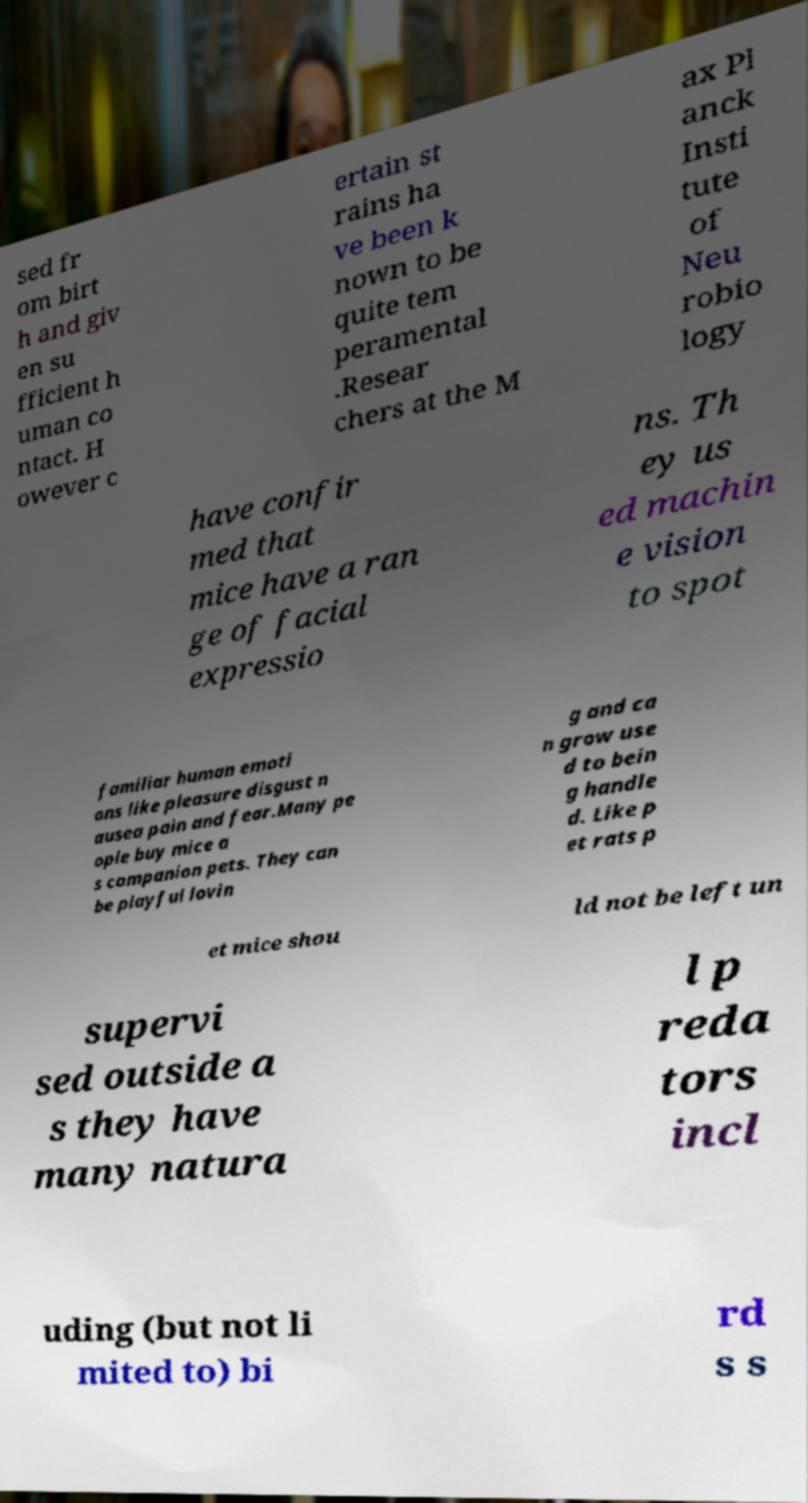Please read and relay the text visible in this image. What does it say? sed fr om birt h and giv en su fficient h uman co ntact. H owever c ertain st rains ha ve been k nown to be quite tem peramental .Resear chers at the M ax Pl anck Insti tute of Neu robio logy have confir med that mice have a ran ge of facial expressio ns. Th ey us ed machin e vision to spot familiar human emoti ons like pleasure disgust n ausea pain and fear.Many pe ople buy mice a s companion pets. They can be playful lovin g and ca n grow use d to bein g handle d. Like p et rats p et mice shou ld not be left un supervi sed outside a s they have many natura l p reda tors incl uding (but not li mited to) bi rd s s 